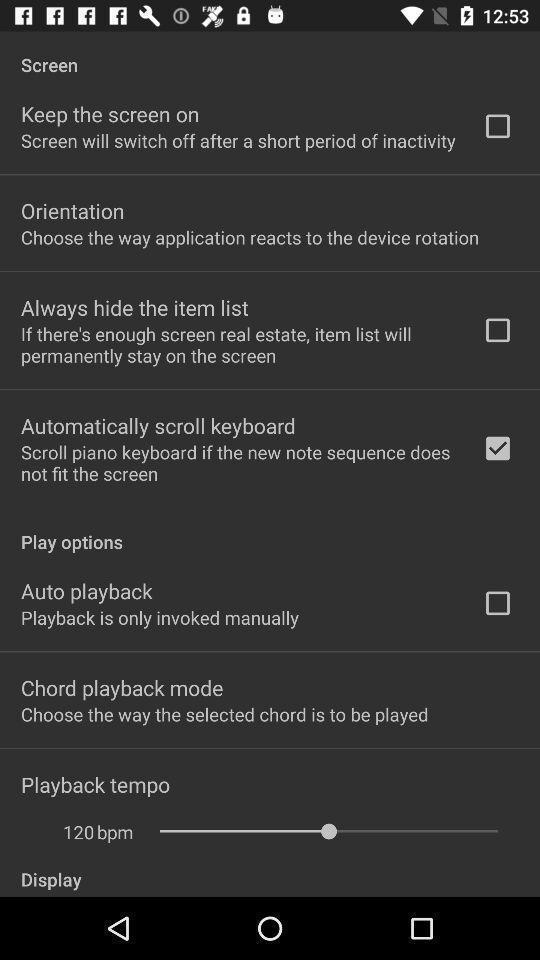Explain what's happening in this screen capture. Page showing screen setting options. 